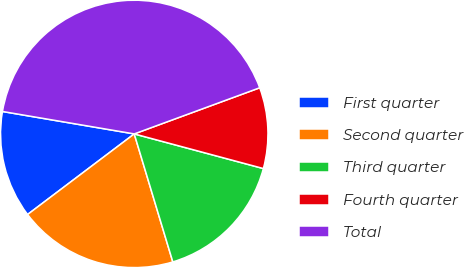Convert chart to OTSL. <chart><loc_0><loc_0><loc_500><loc_500><pie_chart><fcel>First quarter<fcel>Second quarter<fcel>Third quarter<fcel>Fourth quarter<fcel>Total<nl><fcel>12.98%<fcel>19.36%<fcel>16.17%<fcel>9.78%<fcel>41.71%<nl></chart> 